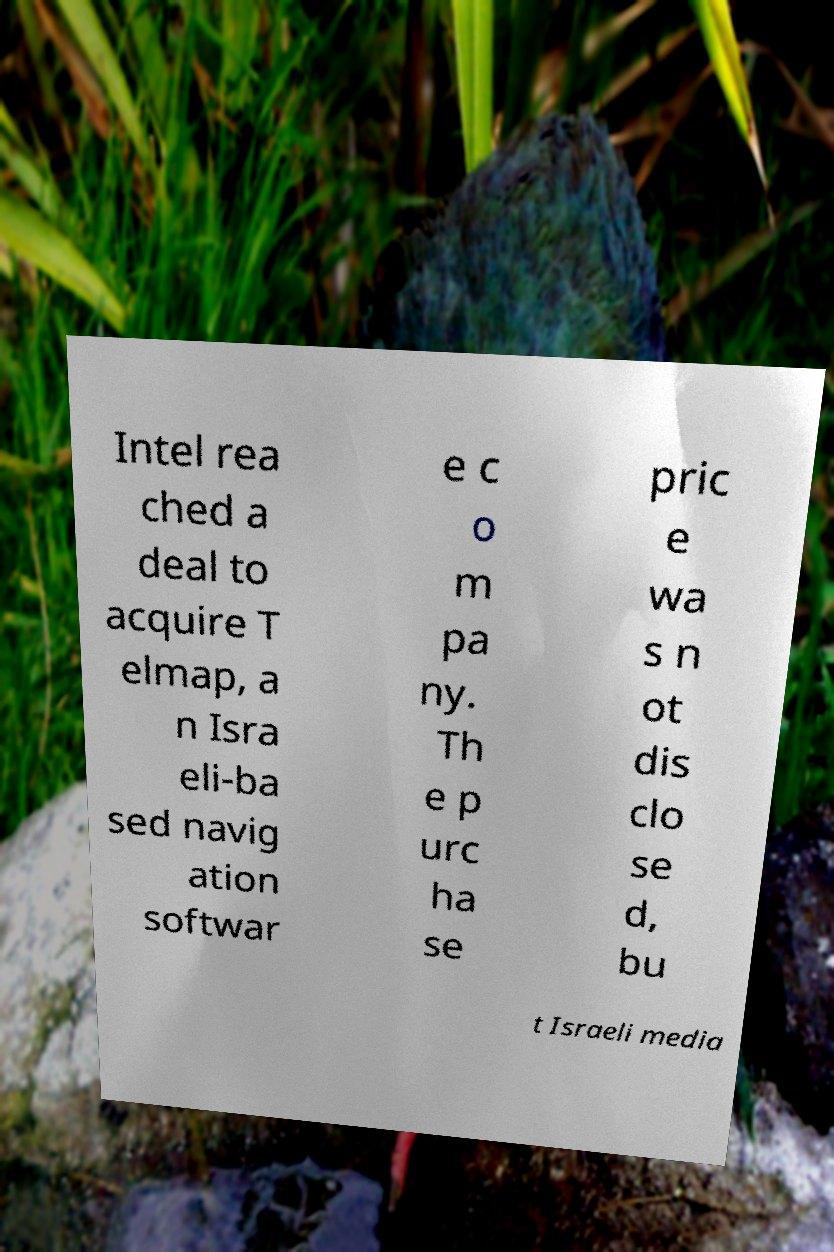For documentation purposes, I need the text within this image transcribed. Could you provide that? Intel rea ched a deal to acquire T elmap, a n Isra eli-ba sed navig ation softwar e c o m pa ny. Th e p urc ha se pric e wa s n ot dis clo se d, bu t Israeli media 